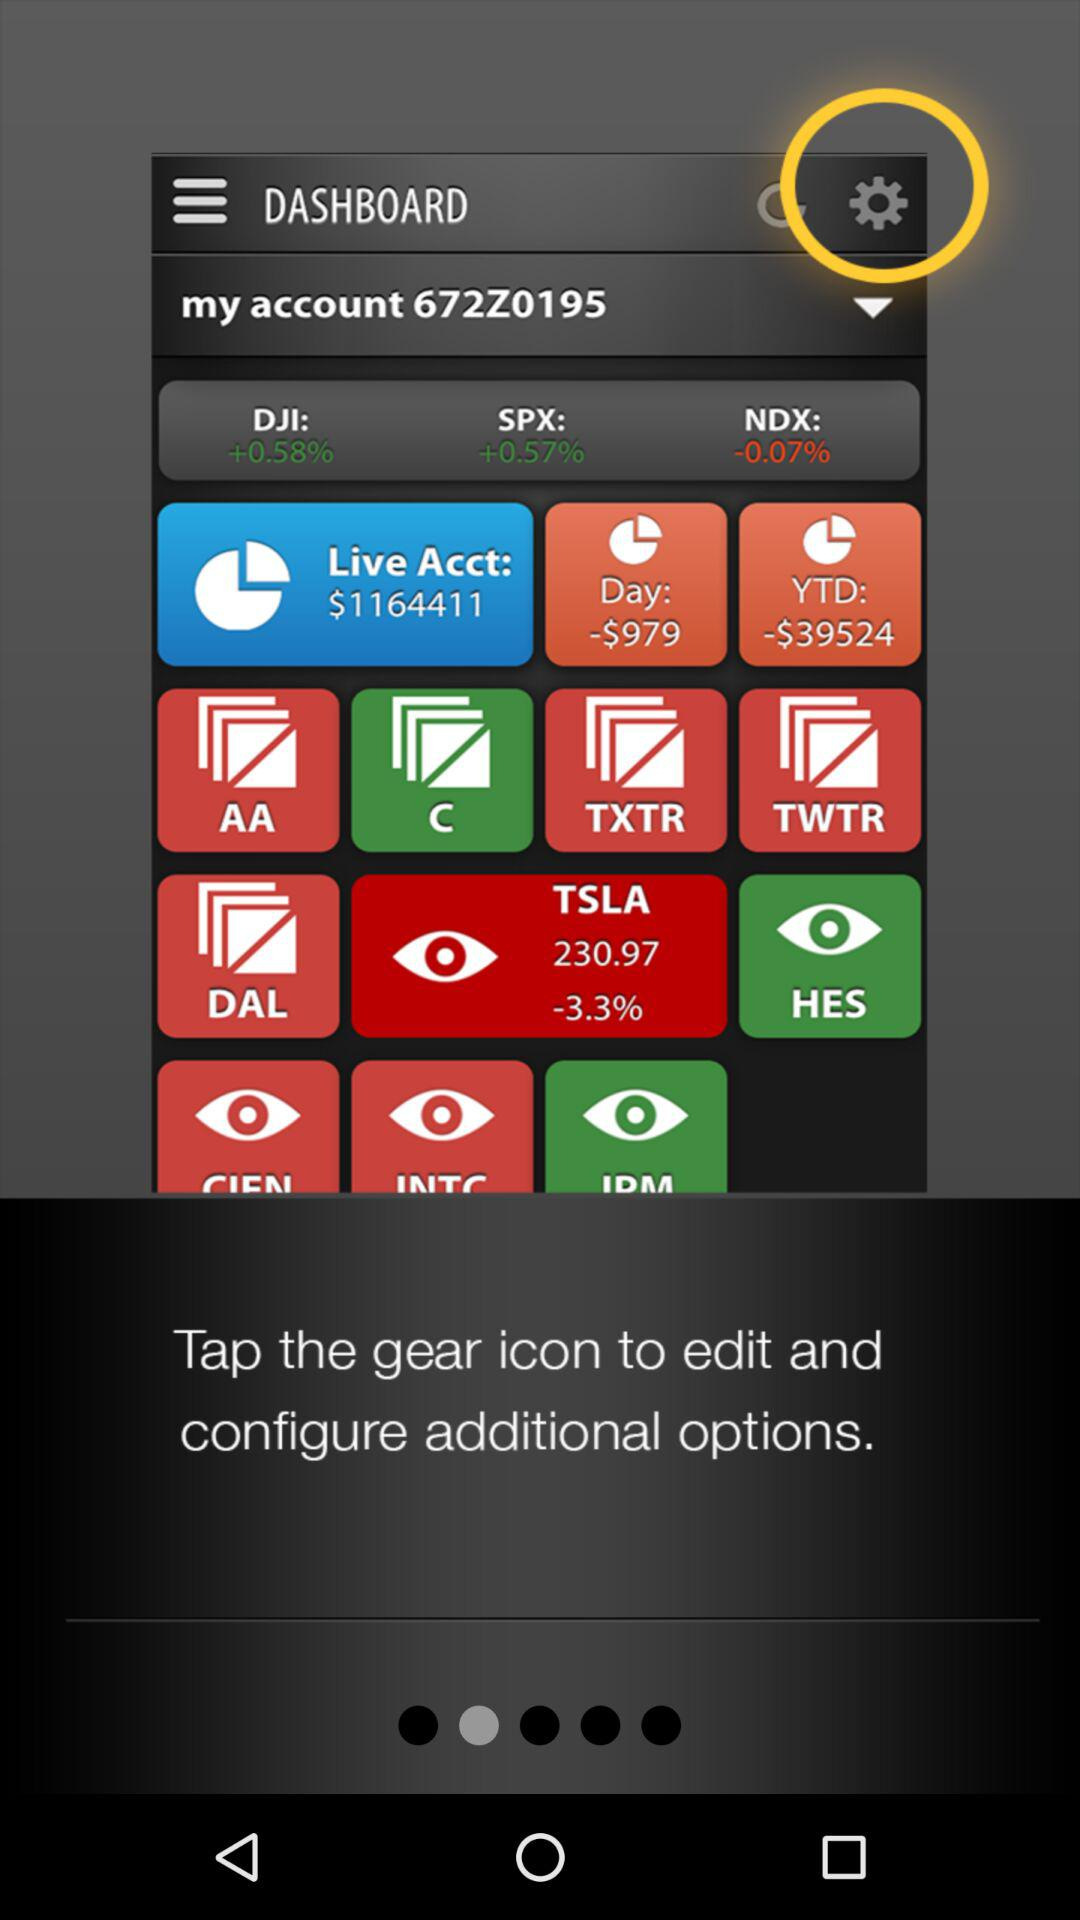What is the account number? The account number is 672Z0195. 